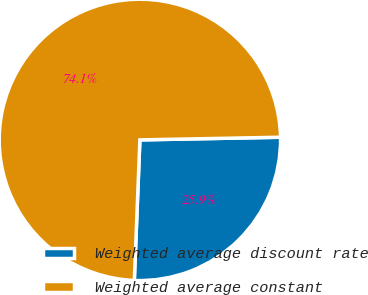Convert chart to OTSL. <chart><loc_0><loc_0><loc_500><loc_500><pie_chart><fcel>Weighted average discount rate<fcel>Weighted average constant<nl><fcel>25.93%<fcel>74.07%<nl></chart> 